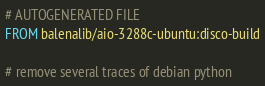<code> <loc_0><loc_0><loc_500><loc_500><_Dockerfile_># AUTOGENERATED FILE
FROM balenalib/aio-3288c-ubuntu:disco-build

# remove several traces of debian python</code> 